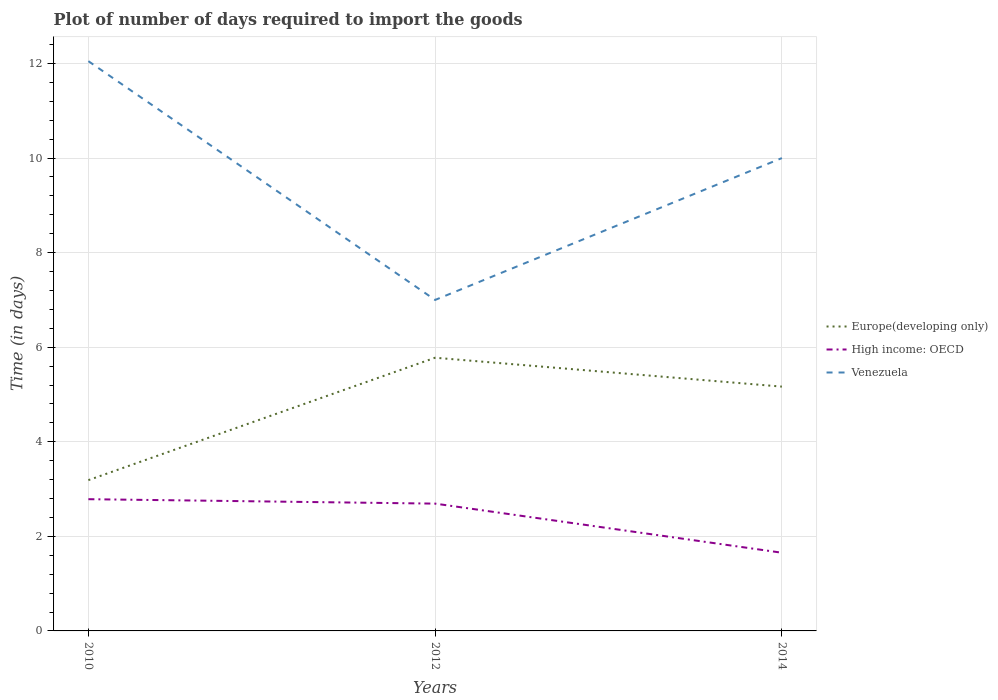Does the line corresponding to Venezuela intersect with the line corresponding to High income: OECD?
Give a very brief answer. No. What is the total time required to import goods in Europe(developing only) in the graph?
Ensure brevity in your answer.  -1.98. What is the difference between the highest and the second highest time required to import goods in High income: OECD?
Offer a very short reply. 1.13. How many years are there in the graph?
Your answer should be very brief. 3. What is the difference between two consecutive major ticks on the Y-axis?
Your answer should be compact. 2. Are the values on the major ticks of Y-axis written in scientific E-notation?
Your response must be concise. No. Does the graph contain any zero values?
Offer a terse response. No. Where does the legend appear in the graph?
Give a very brief answer. Center right. How are the legend labels stacked?
Your answer should be compact. Vertical. What is the title of the graph?
Your answer should be very brief. Plot of number of days required to import the goods. Does "Andorra" appear as one of the legend labels in the graph?
Give a very brief answer. No. What is the label or title of the X-axis?
Offer a terse response. Years. What is the label or title of the Y-axis?
Your response must be concise. Time (in days). What is the Time (in days) of Europe(developing only) in 2010?
Offer a terse response. 3.19. What is the Time (in days) in High income: OECD in 2010?
Your response must be concise. 2.79. What is the Time (in days) in Venezuela in 2010?
Ensure brevity in your answer.  12.05. What is the Time (in days) of Europe(developing only) in 2012?
Give a very brief answer. 5.78. What is the Time (in days) of High income: OECD in 2012?
Offer a very short reply. 2.69. What is the Time (in days) of Venezuela in 2012?
Your response must be concise. 7. What is the Time (in days) of Europe(developing only) in 2014?
Provide a succinct answer. 5.17. What is the Time (in days) in High income: OECD in 2014?
Offer a very short reply. 1.65. What is the Time (in days) of Venezuela in 2014?
Ensure brevity in your answer.  10. Across all years, what is the maximum Time (in days) of Europe(developing only)?
Offer a terse response. 5.78. Across all years, what is the maximum Time (in days) of High income: OECD?
Keep it short and to the point. 2.79. Across all years, what is the maximum Time (in days) in Venezuela?
Keep it short and to the point. 12.05. Across all years, what is the minimum Time (in days) of Europe(developing only)?
Your response must be concise. 3.19. Across all years, what is the minimum Time (in days) in High income: OECD?
Ensure brevity in your answer.  1.65. Across all years, what is the minimum Time (in days) in Venezuela?
Ensure brevity in your answer.  7. What is the total Time (in days) of Europe(developing only) in the graph?
Keep it short and to the point. 14.13. What is the total Time (in days) in High income: OECD in the graph?
Ensure brevity in your answer.  7.13. What is the total Time (in days) of Venezuela in the graph?
Your answer should be very brief. 29.05. What is the difference between the Time (in days) in Europe(developing only) in 2010 and that in 2012?
Provide a short and direct response. -2.59. What is the difference between the Time (in days) of High income: OECD in 2010 and that in 2012?
Make the answer very short. 0.09. What is the difference between the Time (in days) of Venezuela in 2010 and that in 2012?
Ensure brevity in your answer.  5.05. What is the difference between the Time (in days) of Europe(developing only) in 2010 and that in 2014?
Your answer should be compact. -1.98. What is the difference between the Time (in days) in High income: OECD in 2010 and that in 2014?
Provide a succinct answer. 1.13. What is the difference between the Time (in days) in Venezuela in 2010 and that in 2014?
Give a very brief answer. 2.05. What is the difference between the Time (in days) in Europe(developing only) in 2012 and that in 2014?
Offer a terse response. 0.61. What is the difference between the Time (in days) in Venezuela in 2012 and that in 2014?
Your answer should be very brief. -3. What is the difference between the Time (in days) in Europe(developing only) in 2010 and the Time (in days) in High income: OECD in 2012?
Keep it short and to the point. 0.5. What is the difference between the Time (in days) in Europe(developing only) in 2010 and the Time (in days) in Venezuela in 2012?
Offer a very short reply. -3.81. What is the difference between the Time (in days) in High income: OECD in 2010 and the Time (in days) in Venezuela in 2012?
Ensure brevity in your answer.  -4.21. What is the difference between the Time (in days) of Europe(developing only) in 2010 and the Time (in days) of High income: OECD in 2014?
Offer a very short reply. 1.53. What is the difference between the Time (in days) of Europe(developing only) in 2010 and the Time (in days) of Venezuela in 2014?
Your answer should be compact. -6.81. What is the difference between the Time (in days) of High income: OECD in 2010 and the Time (in days) of Venezuela in 2014?
Your response must be concise. -7.21. What is the difference between the Time (in days) of Europe(developing only) in 2012 and the Time (in days) of High income: OECD in 2014?
Offer a terse response. 4.12. What is the difference between the Time (in days) of Europe(developing only) in 2012 and the Time (in days) of Venezuela in 2014?
Ensure brevity in your answer.  -4.22. What is the difference between the Time (in days) of High income: OECD in 2012 and the Time (in days) of Venezuela in 2014?
Provide a succinct answer. -7.31. What is the average Time (in days) in Europe(developing only) per year?
Ensure brevity in your answer.  4.71. What is the average Time (in days) in High income: OECD per year?
Offer a very short reply. 2.38. What is the average Time (in days) in Venezuela per year?
Offer a terse response. 9.68. In the year 2010, what is the difference between the Time (in days) of Europe(developing only) and Time (in days) of High income: OECD?
Your response must be concise. 0.4. In the year 2010, what is the difference between the Time (in days) of Europe(developing only) and Time (in days) of Venezuela?
Ensure brevity in your answer.  -8.86. In the year 2010, what is the difference between the Time (in days) in High income: OECD and Time (in days) in Venezuela?
Provide a short and direct response. -9.26. In the year 2012, what is the difference between the Time (in days) in Europe(developing only) and Time (in days) in High income: OECD?
Your response must be concise. 3.09. In the year 2012, what is the difference between the Time (in days) in Europe(developing only) and Time (in days) in Venezuela?
Your answer should be compact. -1.22. In the year 2012, what is the difference between the Time (in days) of High income: OECD and Time (in days) of Venezuela?
Ensure brevity in your answer.  -4.31. In the year 2014, what is the difference between the Time (in days) in Europe(developing only) and Time (in days) in High income: OECD?
Give a very brief answer. 3.51. In the year 2014, what is the difference between the Time (in days) of Europe(developing only) and Time (in days) of Venezuela?
Offer a terse response. -4.83. In the year 2014, what is the difference between the Time (in days) of High income: OECD and Time (in days) of Venezuela?
Your answer should be very brief. -8.35. What is the ratio of the Time (in days) in Europe(developing only) in 2010 to that in 2012?
Give a very brief answer. 0.55. What is the ratio of the Time (in days) of High income: OECD in 2010 to that in 2012?
Provide a short and direct response. 1.03. What is the ratio of the Time (in days) of Venezuela in 2010 to that in 2012?
Provide a succinct answer. 1.72. What is the ratio of the Time (in days) in Europe(developing only) in 2010 to that in 2014?
Provide a short and direct response. 0.62. What is the ratio of the Time (in days) of High income: OECD in 2010 to that in 2014?
Make the answer very short. 1.68. What is the ratio of the Time (in days) of Venezuela in 2010 to that in 2014?
Provide a short and direct response. 1.21. What is the ratio of the Time (in days) in Europe(developing only) in 2012 to that in 2014?
Keep it short and to the point. 1.12. What is the ratio of the Time (in days) in High income: OECD in 2012 to that in 2014?
Provide a short and direct response. 1.63. What is the difference between the highest and the second highest Time (in days) of Europe(developing only)?
Provide a succinct answer. 0.61. What is the difference between the highest and the second highest Time (in days) of High income: OECD?
Keep it short and to the point. 0.09. What is the difference between the highest and the second highest Time (in days) of Venezuela?
Give a very brief answer. 2.05. What is the difference between the highest and the lowest Time (in days) of Europe(developing only)?
Provide a succinct answer. 2.59. What is the difference between the highest and the lowest Time (in days) in High income: OECD?
Make the answer very short. 1.13. What is the difference between the highest and the lowest Time (in days) of Venezuela?
Offer a terse response. 5.05. 